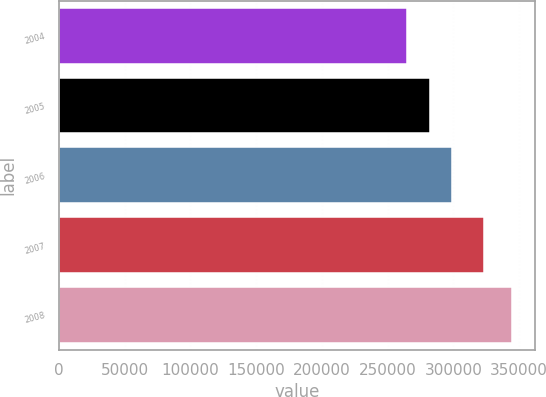Convert chart. <chart><loc_0><loc_0><loc_500><loc_500><bar_chart><fcel>2004<fcel>2005<fcel>2006<fcel>2007<fcel>2008<nl><fcel>265000<fcel>282000<fcel>299000<fcel>323000<fcel>345000<nl></chart> 